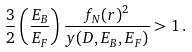Convert formula to latex. <formula><loc_0><loc_0><loc_500><loc_500>\frac { 3 } { 2 } \left ( \frac { E _ { B } } { E _ { F } } \right ) \frac { f _ { N } ( r ) ^ { 2 } } { y ( D , E _ { B } , E _ { F } ) } > 1 \, .</formula> 